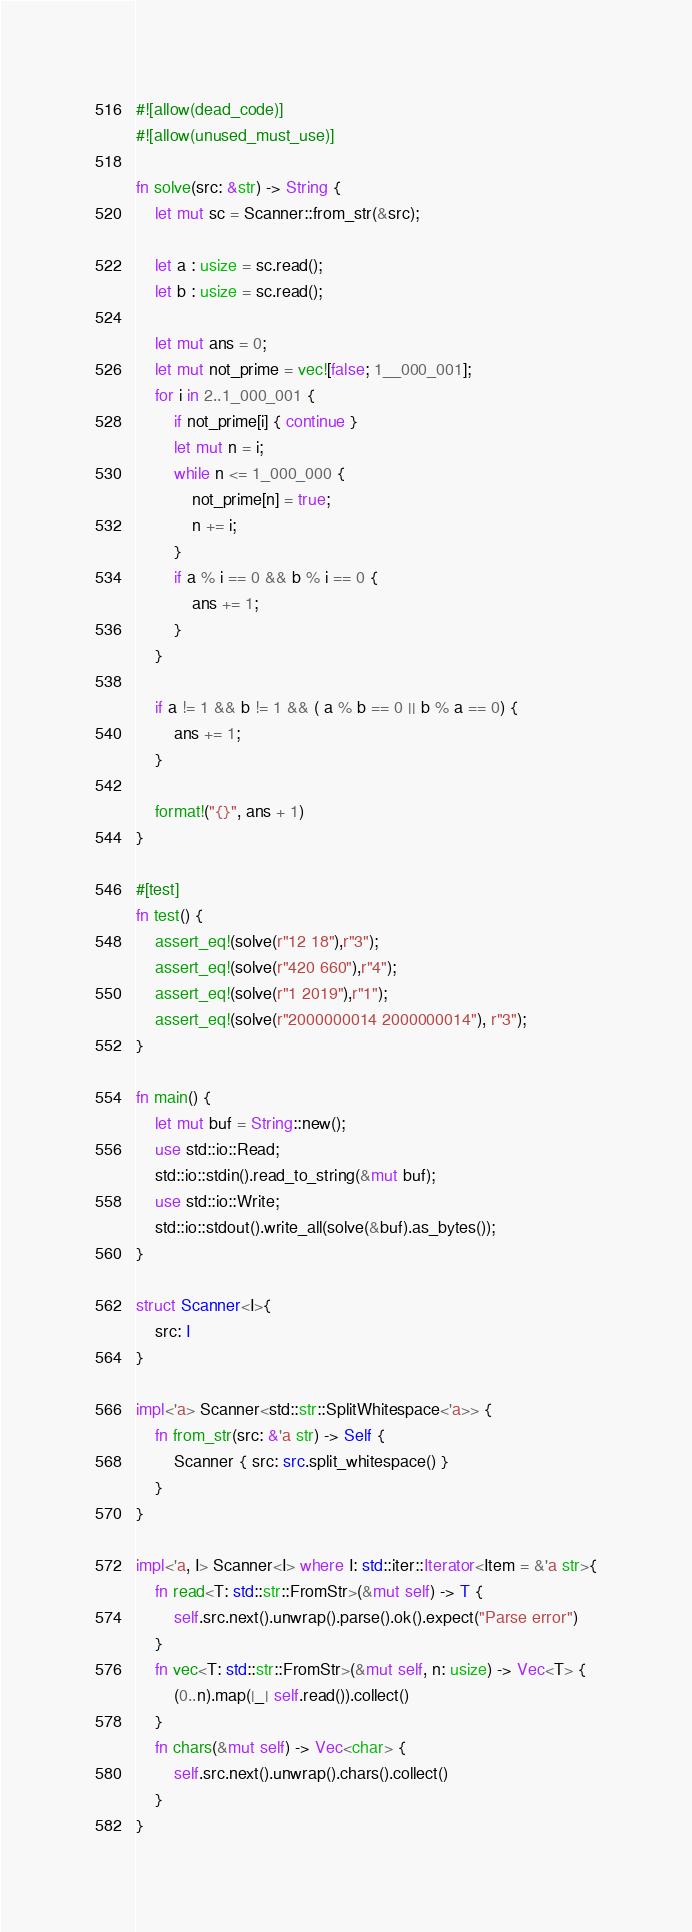<code> <loc_0><loc_0><loc_500><loc_500><_Rust_>#![allow(dead_code)]
#![allow(unused_must_use)]

fn solve(src: &str) -> String {
    let mut sc = Scanner::from_str(&src);

    let a : usize = sc.read();
    let b : usize = sc.read();

    let mut ans = 0;
    let mut not_prime = vec![false; 1__000_001];
    for i in 2..1_000_001 {
        if not_prime[i] { continue }
        let mut n = i;
        while n <= 1_000_000 {
            not_prime[n] = true;
            n += i;
        }
        if a % i == 0 && b % i == 0 {
            ans += 1;
        }
    }

    if a != 1 && b != 1 && ( a % b == 0 || b % a == 0) {
        ans += 1;
    }

    format!("{}", ans + 1)
}

#[test]
fn test() {
    assert_eq!(solve(r"12 18"),r"3");
    assert_eq!(solve(r"420 660"),r"4");
    assert_eq!(solve(r"1 2019"),r"1");
    assert_eq!(solve(r"2000000014 2000000014"), r"3");
}

fn main() {
    let mut buf = String::new();
    use std::io::Read;
    std::io::stdin().read_to_string(&mut buf);
    use std::io::Write;
    std::io::stdout().write_all(solve(&buf).as_bytes());
}

struct Scanner<I>{
    src: I
}

impl<'a> Scanner<std::str::SplitWhitespace<'a>> {
    fn from_str(src: &'a str) -> Self {
        Scanner { src: src.split_whitespace() }
    }
}

impl<'a, I> Scanner<I> where I: std::iter::Iterator<Item = &'a str>{
    fn read<T: std::str::FromStr>(&mut self) -> T {
        self.src.next().unwrap().parse().ok().expect("Parse error")
    }
    fn vec<T: std::str::FromStr>(&mut self, n: usize) -> Vec<T> {
        (0..n).map(|_| self.read()).collect()
    }
    fn chars(&mut self) -> Vec<char> {
        self.src.next().unwrap().chars().collect()
    }
}</code> 